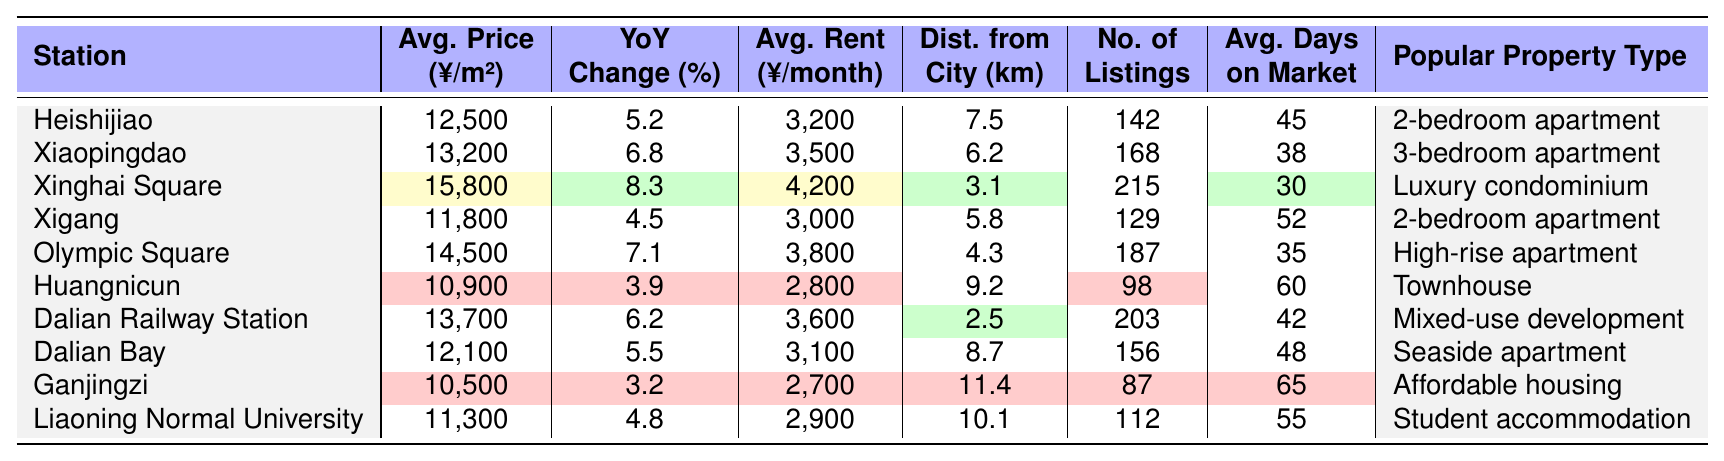What is the average price per square meter at Xinghai Square? The table lists the average price per square meter for each station. For Xinghai Square, this value is provided directly in the table under the "Avg. Price (¥/m²)" column, which is 15,800.
Answer: 15,800 Which station has the highest average rent per month? Looking at the "Avg. Rent (¥/month)" column, we identify the highest value among all stations. The highest rent is at Xinghai Square, which is 4,200.
Answer: 4,200 What is the year-on-year change for Ganjingzi? The year-on-year change for each station is included in the table. For Ganjingzi, the value is 3.2%, which can be found under the "YoY Change (%)" column.
Answer: 3.2 How does the average price per square meter at Dalian Railway Station compare to the average price at Olympic Square? The average price per square meter at Dalian Railway Station is 13,700, and at Olympic Square, it is 14,500. Comparing these prices shows that Olympic Square is more expensive by 800.
Answer: Olympic Square is more expensive by 800 What is the total number of listings at Heishijiao and Xigang combined? The total number of listings can be found for each station. Heishijiao has 142 listings and Xigang has 129 listings. Adding these values together gives 142 + 129 = 271.
Answer: 271 Is the average days on market for Huangnicun greater than the average days on market for Liaoning Normal University? The average days on market are listed as 60 for Huangnicun and 55 for Liaoning Normal University. Since 60 is greater than 55, the statement is true.
Answer: Yes What is the distance from Dalian Bay to the city center? The table indicates the distance from the city center for each station. For Dalian Bay, this value is 8.7 kilometers.
Answer: 8.7 Which station has the lowest average price per square meter and what is that price? The average prices per square meter are listed for each station, and the lowest value is found under Ganjingzi, which is 10,500.
Answer: 10,500 If you wanted the cheapest average rent, which station would you choose? The "Avg. Rent (¥/month)" column shows the values for each station, and the lowest average rent is at Huangnicun, which is 2,800.
Answer: Huangnicun How many more days, on average, does a property at Xigang stay on the market compared to one at Dalian Bay? The average days on market for Xigang is 52 and for Dalian Bay is 48. The difference is calculated as 52 - 48 = 4 days.
Answer: 4 days What type of property is popular in Olympic Square? The popular property type is listed in the last column of the table for Olympic Square, which is a high-rise apartment.
Answer: High-rise apartment 